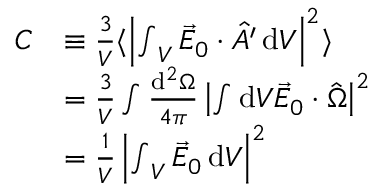Convert formula to latex. <formula><loc_0><loc_0><loc_500><loc_500>\begin{array} { r l } { C } & { \equiv \frac { 3 } { V } \langle \left | { \int } _ { V } \, \vec { E } _ { 0 } \cdot \hat { A ^ { \prime } } \, d V \right | ^ { 2 } \rangle } \\ & { = \frac { 3 } { V } \int \frac { d ^ { 2 } \Omega } { 4 \pi } \left | \int d V \vec { E } _ { 0 } \cdot \hat { \Omega } \right | ^ { 2 } } \\ & { = \frac { 1 } { V } \left | { \int } _ { V } \, \vec { E } _ { 0 } \, d V \right | ^ { 2 } } \end{array}</formula> 